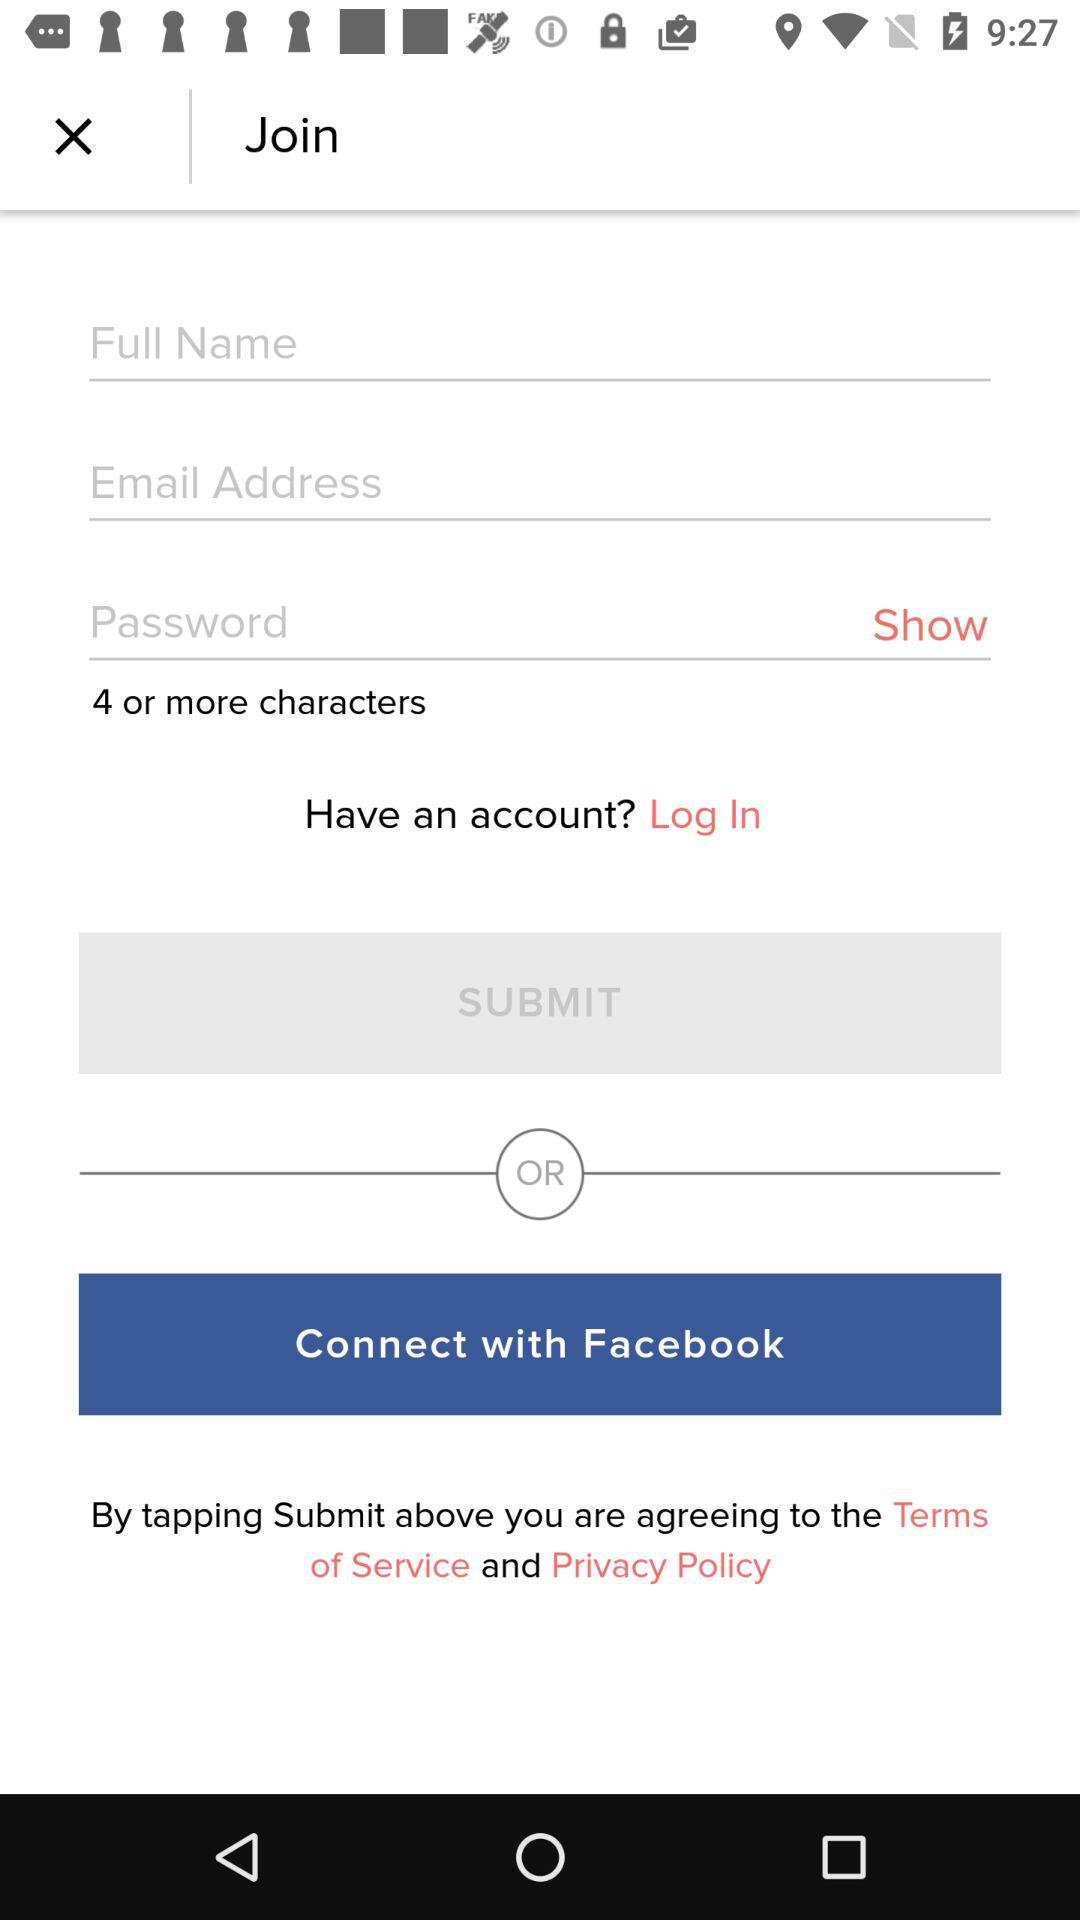How many minimum characters must be in the password? There must be a minimum of 4 characters. 